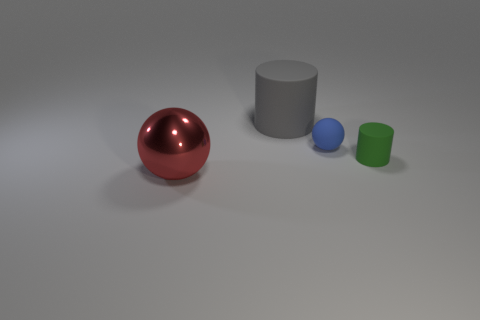Subtract 2 cylinders. How many cylinders are left? 0 Subtract all red cylinders. Subtract all brown blocks. How many cylinders are left? 2 Subtract all yellow cubes. How many gray cylinders are left? 1 Subtract all large red things. Subtract all blue rubber blocks. How many objects are left? 3 Add 3 big gray objects. How many big gray objects are left? 4 Add 3 small green rubber cylinders. How many small green rubber cylinders exist? 4 Add 1 big yellow matte balls. How many objects exist? 5 Subtract 1 green cylinders. How many objects are left? 3 